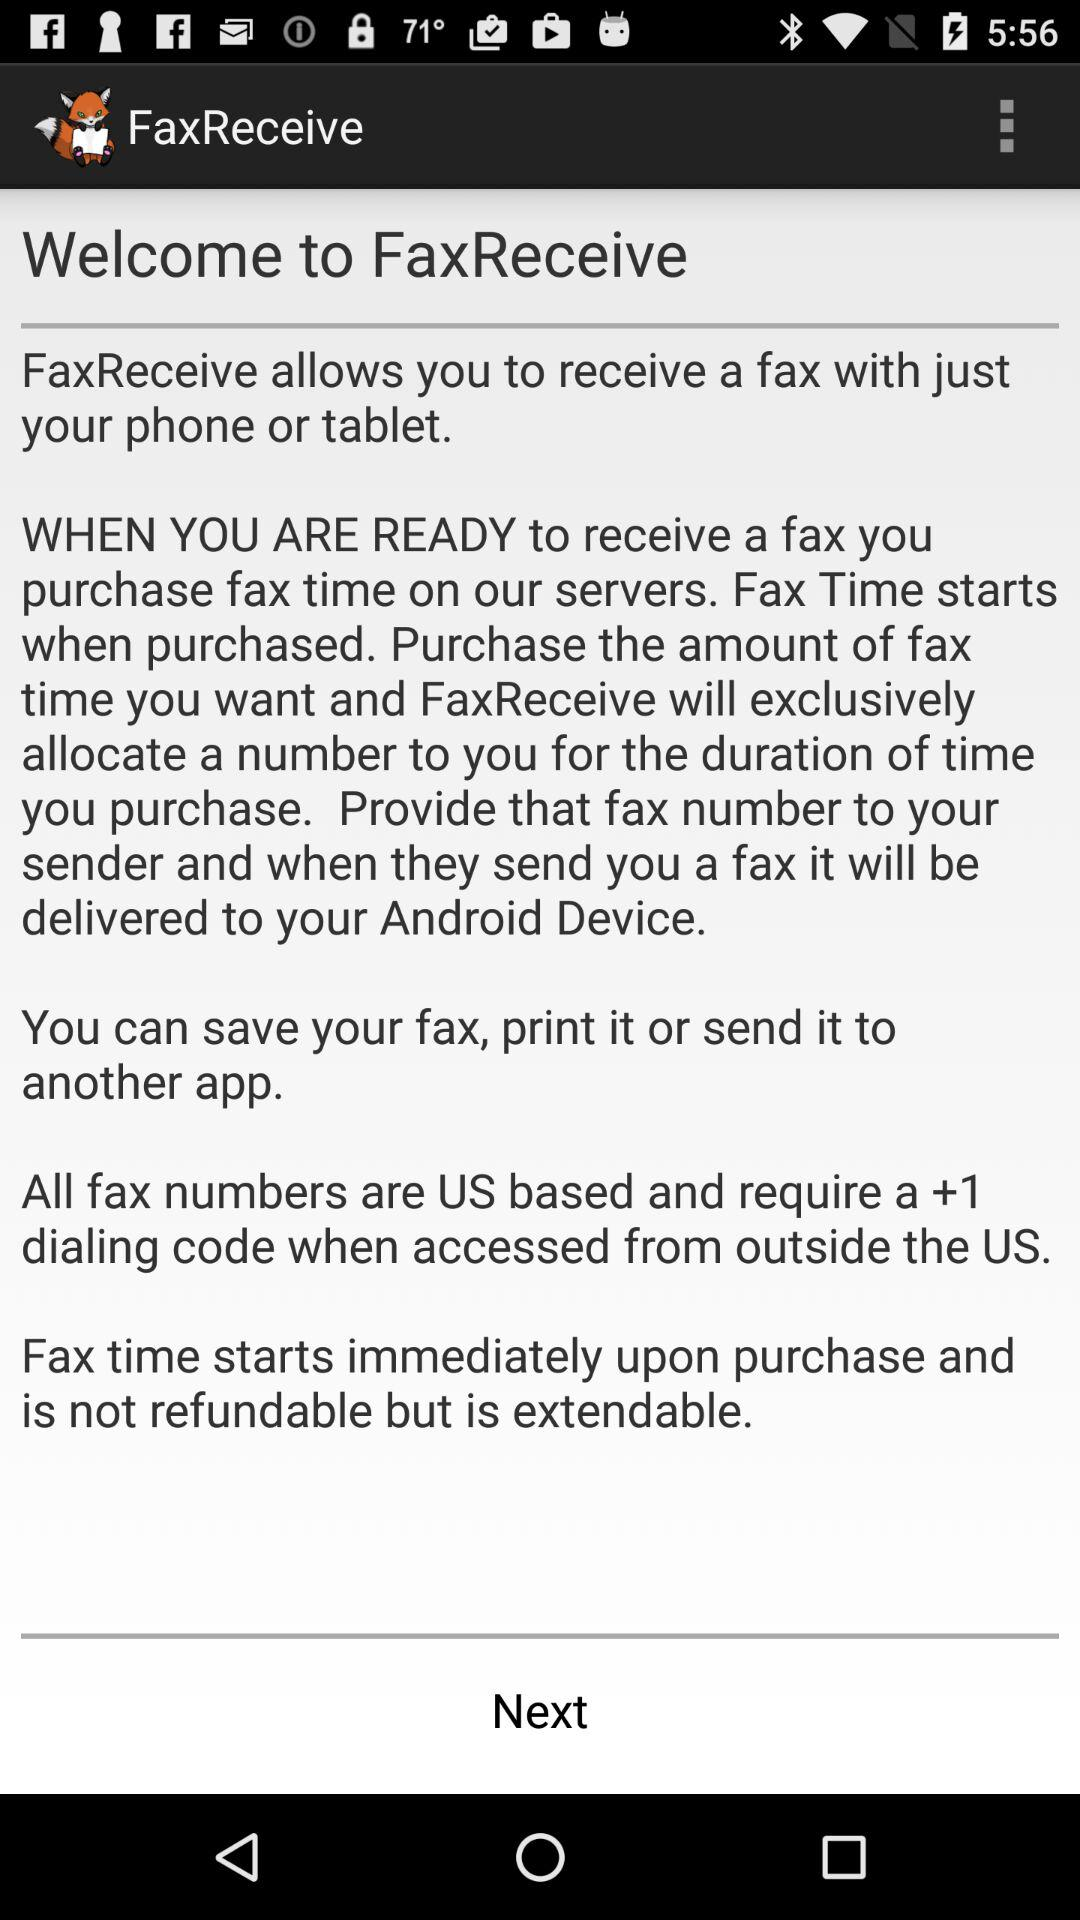What is the name of the application? The name of the application is "FaxReceive". 